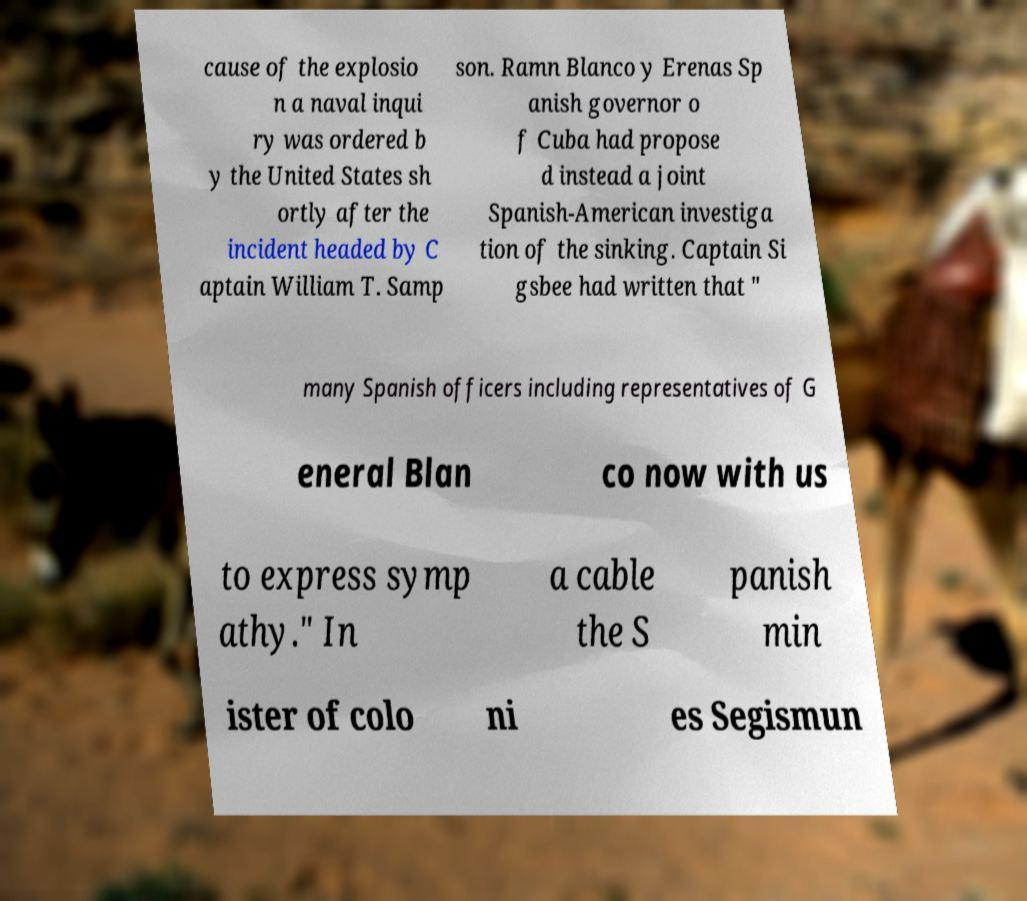There's text embedded in this image that I need extracted. Can you transcribe it verbatim? cause of the explosio n a naval inqui ry was ordered b y the United States sh ortly after the incident headed by C aptain William T. Samp son. Ramn Blanco y Erenas Sp anish governor o f Cuba had propose d instead a joint Spanish-American investiga tion of the sinking. Captain Si gsbee had written that " many Spanish officers including representatives of G eneral Blan co now with us to express symp athy." In a cable the S panish min ister of colo ni es Segismun 